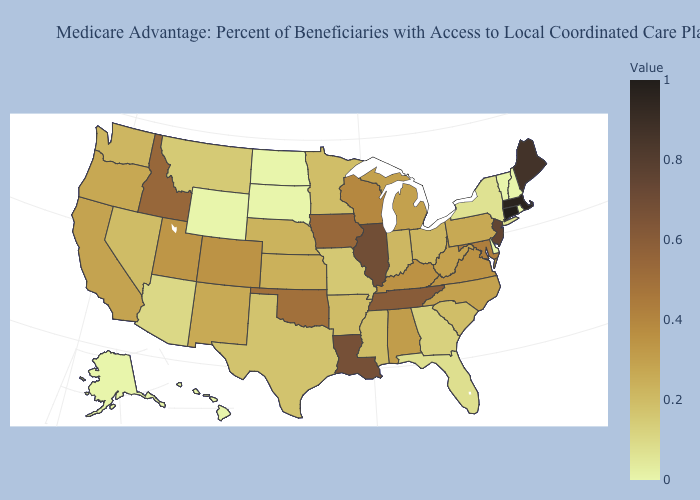Does California have a lower value than Oklahoma?
Write a very short answer. Yes. Among the states that border Pennsylvania , does West Virginia have the highest value?
Write a very short answer. No. Which states have the lowest value in the West?
Give a very brief answer. Alaska, Hawaii, Wyoming. Which states have the lowest value in the MidWest?
Be succinct. North Dakota, South Dakota. Which states have the highest value in the USA?
Quick response, please. Connecticut. Does Illinois have the highest value in the MidWest?
Short answer required. Yes. Which states have the lowest value in the Northeast?
Concise answer only. New Hampshire, Rhode Island, Vermont. 